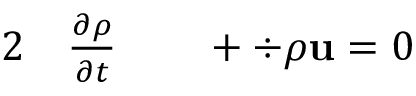<formula> <loc_0><loc_0><loc_500><loc_500>\begin{array} { r l r l } { 2 } & \frac { \partial \rho } { \partial t } } & + \div { \rho u } = 0 } \end{array}</formula> 